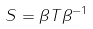<formula> <loc_0><loc_0><loc_500><loc_500>S = \beta T \beta ^ { - 1 }</formula> 